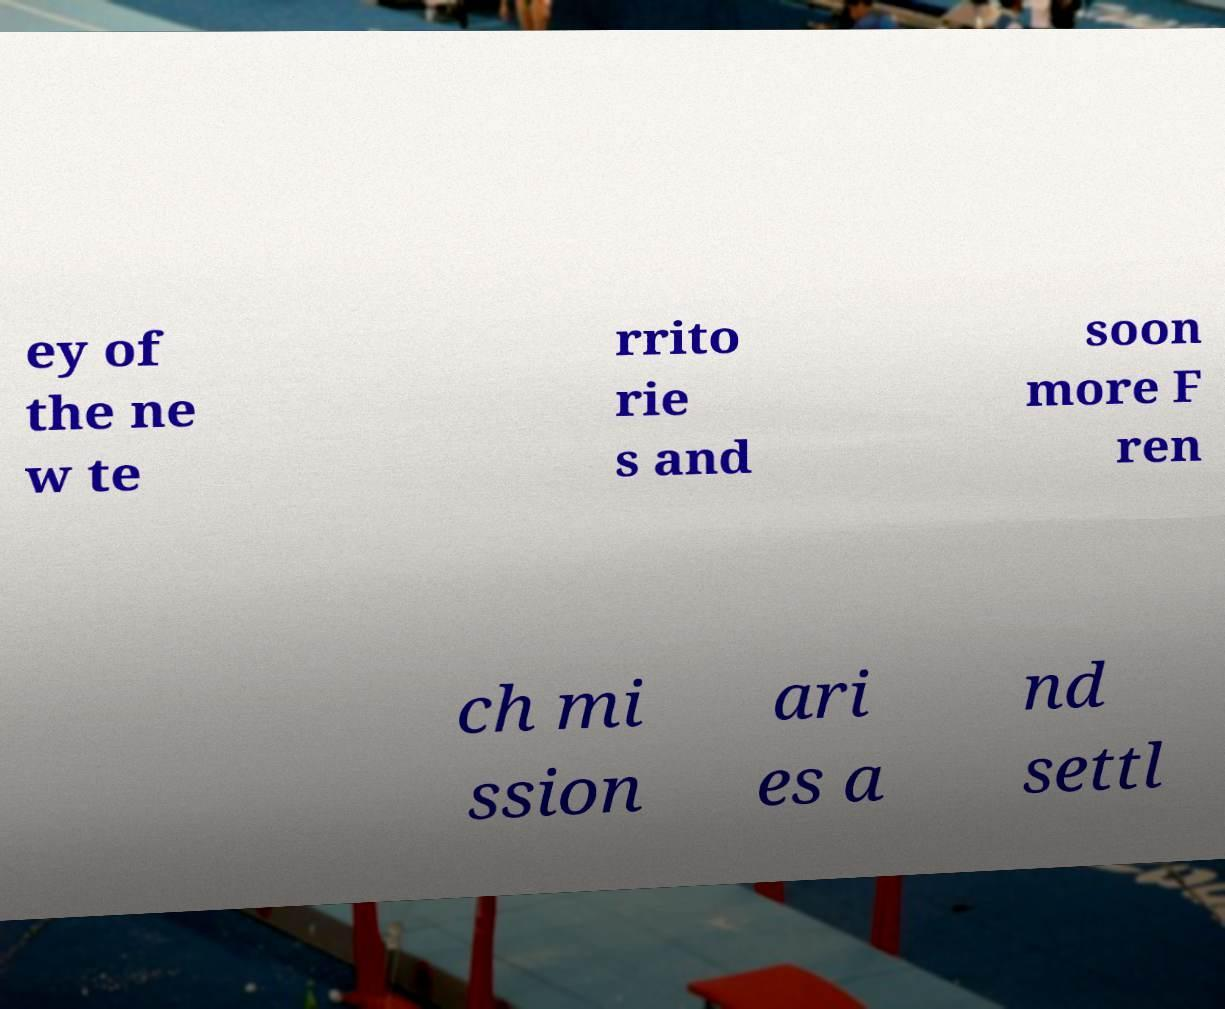Please identify and transcribe the text found in this image. ey of the ne w te rrito rie s and soon more F ren ch mi ssion ari es a nd settl 